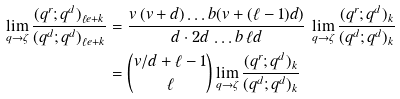Convert formula to latex. <formula><loc_0><loc_0><loc_500><loc_500>\lim _ { q \to \zeta } \frac { ( q ^ { r } ; q ^ { d } ) _ { \ell e + k } } { ( q ^ { d } ; q ^ { d } ) _ { \ell e + k } } & = \frac { v \, ( v + d ) \dots b ( v + ( \ell - 1 ) d ) } { d \cdot 2 d \, \dots b \, \ell d } \, \lim _ { q \to \zeta } \frac { ( q ^ { r } ; q ^ { d } ) _ { k } } { ( q ^ { d } ; q ^ { d } ) _ { k } } \\ & = { v / d + \ell - 1 \choose \ell } \lim _ { q \to \zeta } \frac { ( q ^ { r } ; q ^ { d } ) _ { k } } { ( q ^ { d } ; q ^ { d } ) _ { k } }</formula> 